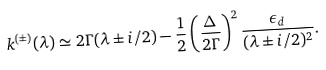Convert formula to latex. <formula><loc_0><loc_0><loc_500><loc_500>k ^ { ( \pm ) } ( \lambda ) \simeq 2 \Gamma ( \lambda \pm i / 2 ) - \frac { 1 } { 2 } \left ( \frac { \Delta } { 2 \Gamma } \right ) ^ { 2 } \frac { \epsilon _ { d } } { ( \lambda \pm i / 2 ) ^ { 2 } } .</formula> 